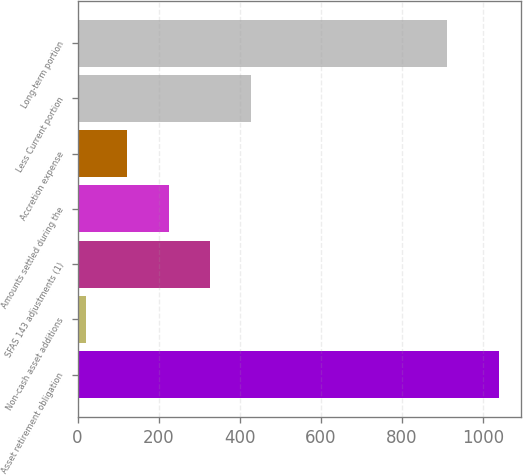Convert chart. <chart><loc_0><loc_0><loc_500><loc_500><bar_chart><fcel>Asset retirement obligation<fcel>Non-cash asset additions<fcel>SFAS 143 adjustments (1)<fcel>Amounts settled during the<fcel>Accretion expense<fcel>Less Current portion<fcel>Long-term portion<nl><fcel>1040.6<fcel>20.5<fcel>326.53<fcel>224.52<fcel>122.51<fcel>428.54<fcel>910<nl></chart> 